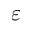<formula> <loc_0><loc_0><loc_500><loc_500>\varepsilon</formula> 